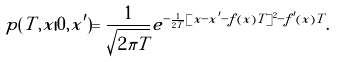<formula> <loc_0><loc_0><loc_500><loc_500>p ( T , x | 0 , x ^ { \prime } ) = \frac { 1 } { \sqrt { 2 \pi T } } e ^ { - \frac { 1 } { 2 T } [ x - x ^ { \prime } - f ( x ) T ] ^ { 2 } - f ^ { \prime } ( x ) T } .</formula> 